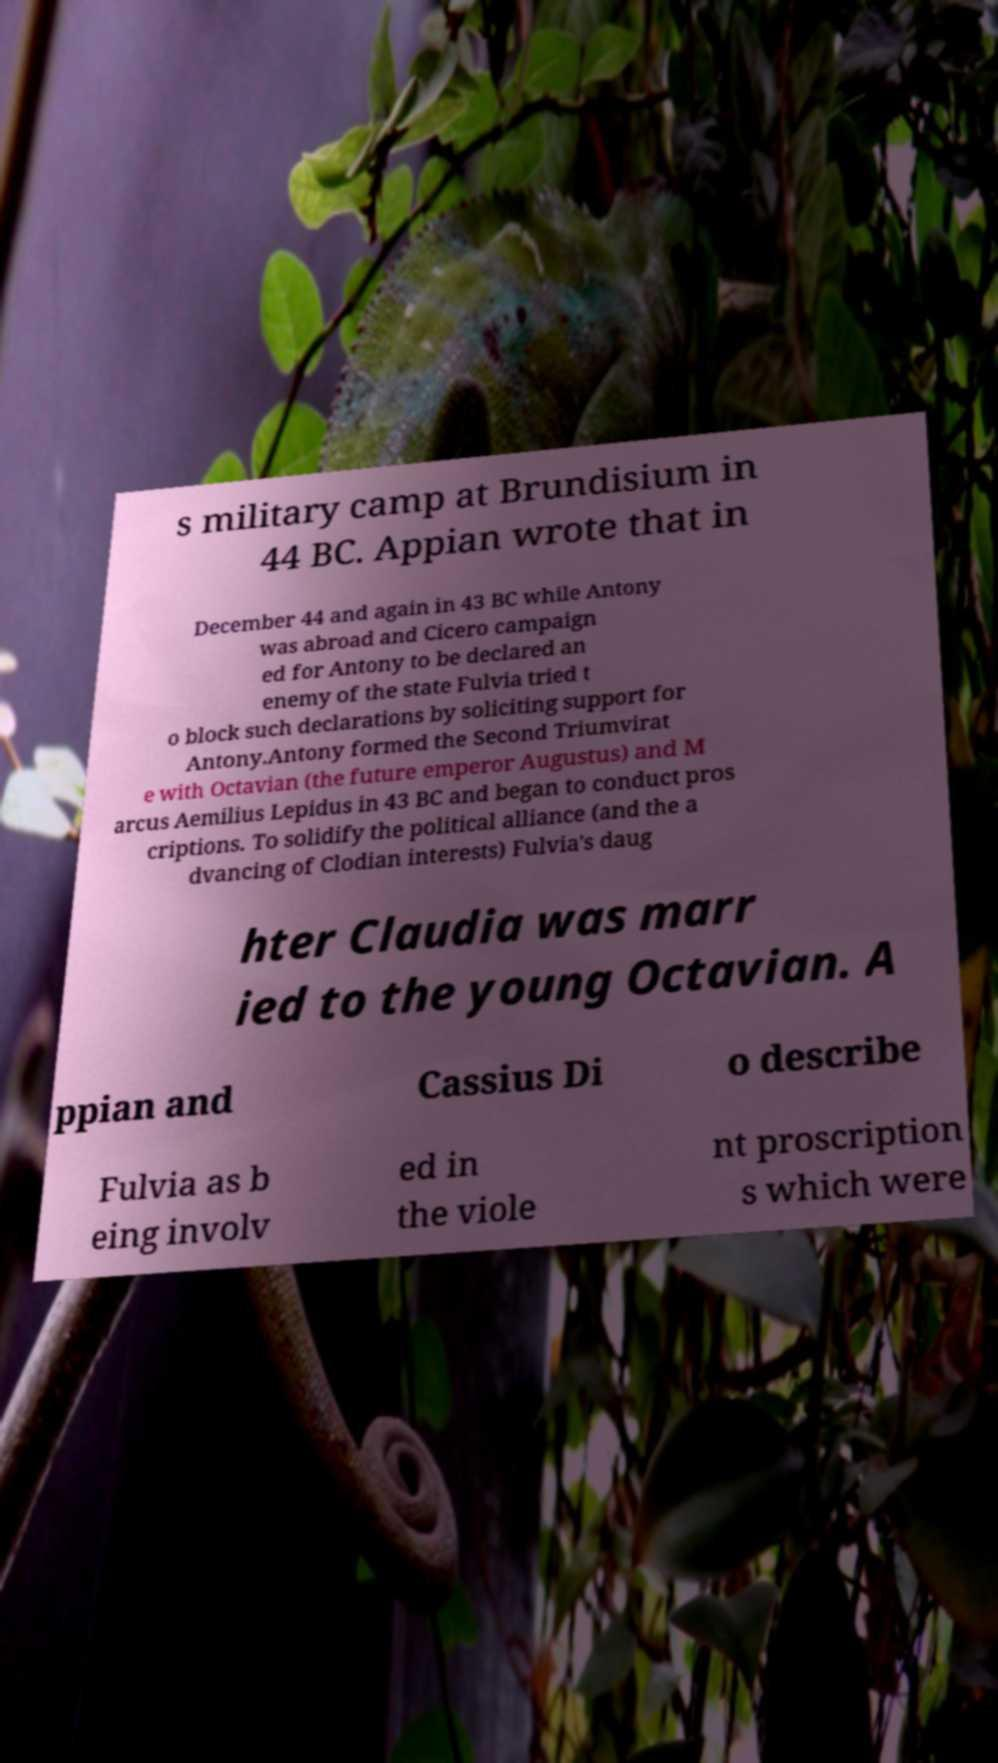What messages or text are displayed in this image? I need them in a readable, typed format. s military camp at Brundisium in 44 BC. Appian wrote that in December 44 and again in 43 BC while Antony was abroad and Cicero campaign ed for Antony to be declared an enemy of the state Fulvia tried t o block such declarations by soliciting support for Antony.Antony formed the Second Triumvirat e with Octavian (the future emperor Augustus) and M arcus Aemilius Lepidus in 43 BC and began to conduct pros criptions. To solidify the political alliance (and the a dvancing of Clodian interests) Fulvia's daug hter Claudia was marr ied to the young Octavian. A ppian and Cassius Di o describe Fulvia as b eing involv ed in the viole nt proscription s which were 